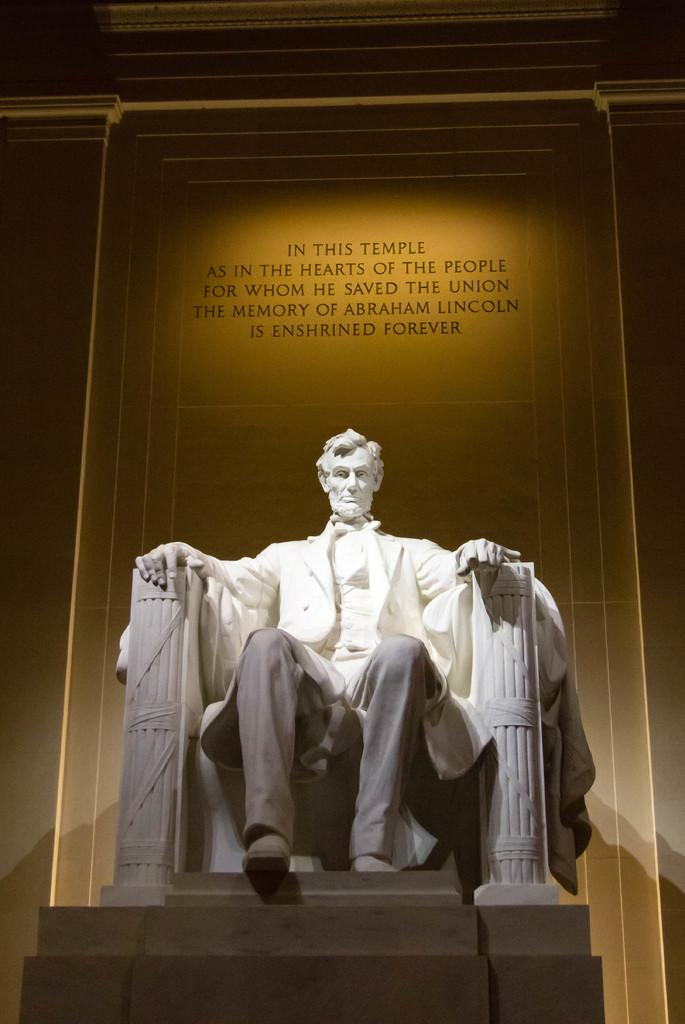What is the main subject of the image? There is a statue of a man sitting in the image. What is located at the base of the statue? There are stairs at the bottom of the statue. What can be seen in the background of the image? There is text on a wall in the background of the image. What type of drain is visible near the statue in the image? There is no drain visible near the statue in the image. 